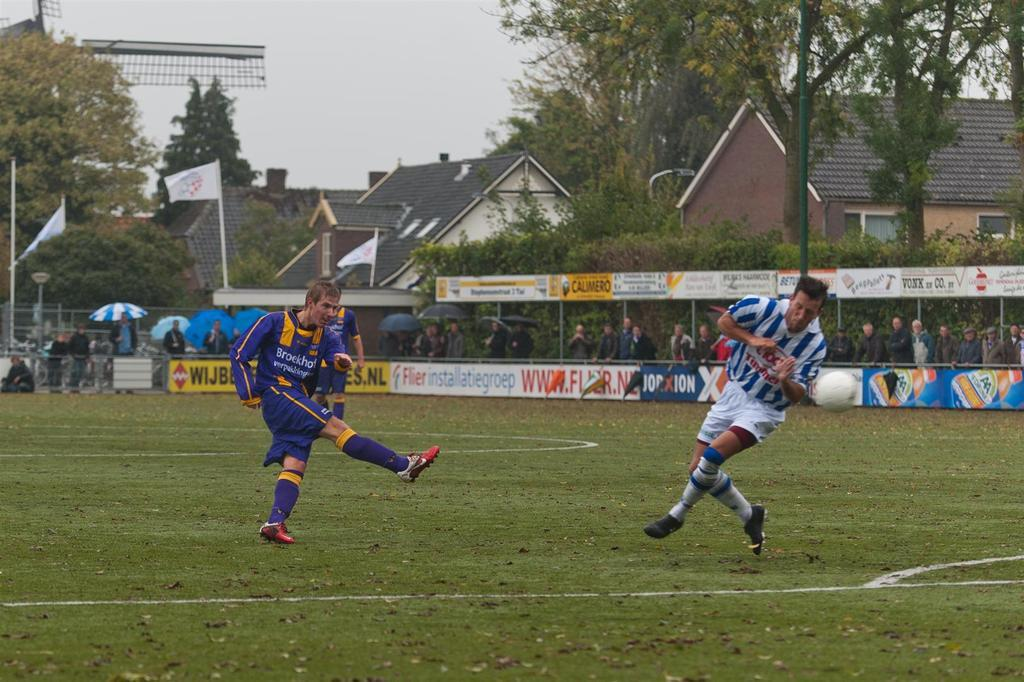<image>
Describe the image concisely. Men playing soccer on a field with a banner for Flier installatiegroep in the background. 